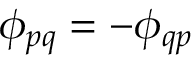Convert formula to latex. <formula><loc_0><loc_0><loc_500><loc_500>\phi _ { p q } = - \phi _ { q p }</formula> 